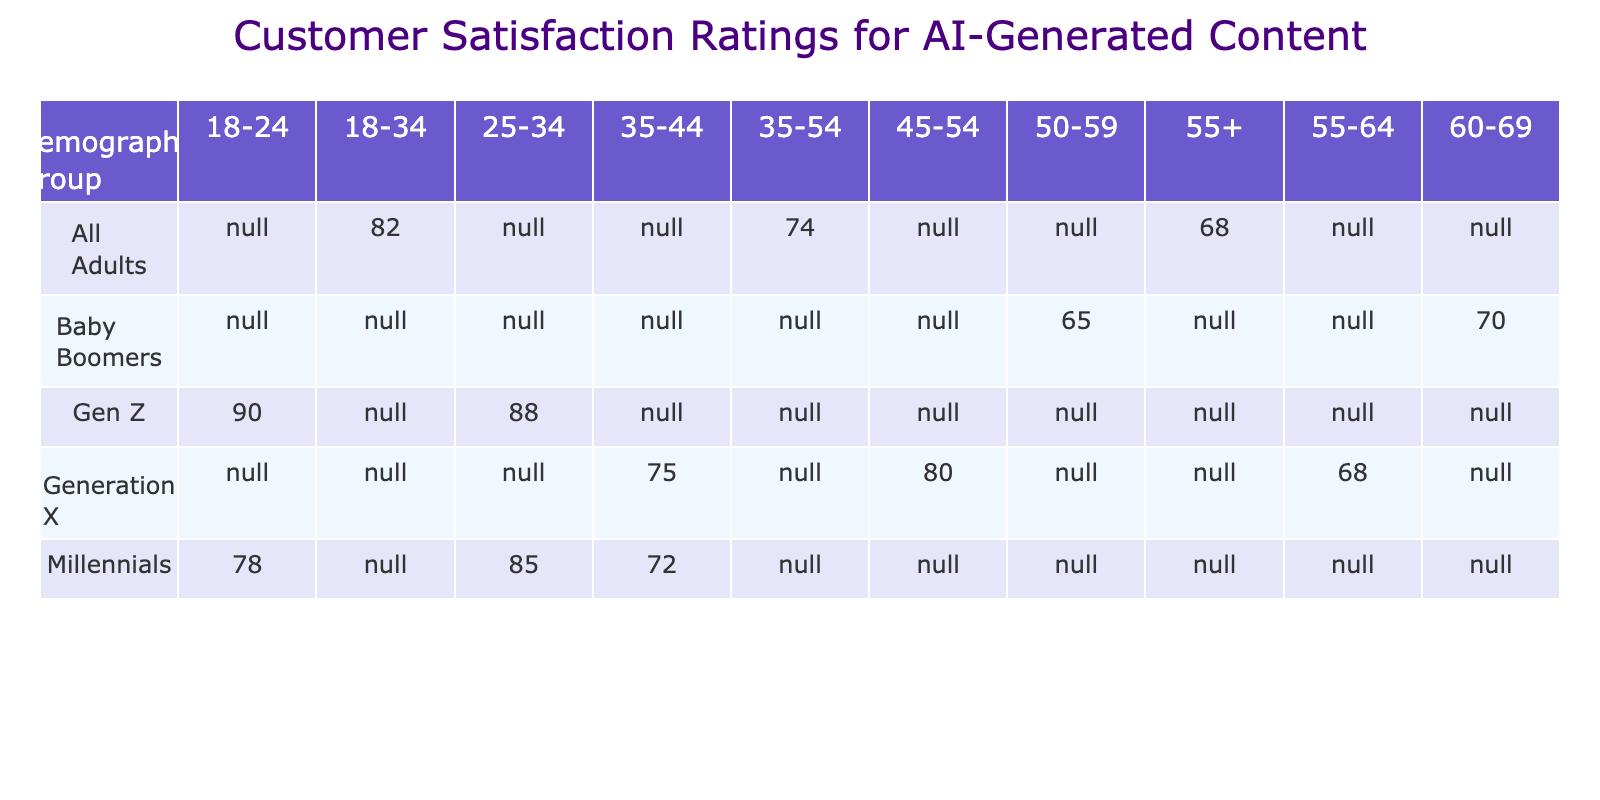What is the satisfaction rating for Gen Z in the 18-24 age group? The table shows the satisfaction rating for Gen Z in the 18-24 age group as 90.
Answer: 90 Which demographic group has the highest satisfaction rating in the age group 25-34? The table indicates that Millennials have the highest satisfaction rating in the 25-34 age group, with a rating of 85.
Answer: Millennials What is the average satisfaction rating for Baby Boomers across all their age groups listed? The ratings for Baby Boomers are 65 (50-59) and 70 (60-69). Adding these gives 135, and dividing by 2 results in an average of 67.5.
Answer: 67.5 Is the satisfaction rating for Generation X in the 55-64 age group higher than that for Baby Boomers in the 60-69 age group? The satisfaction rating for Generation X in the 55-64 age group is 68, while for Baby Boomers in the 60-69 age group it is 70. Therefore, it is false that Generation X has a higher rating.
Answer: No What is the difference between the highest and lowest satisfaction ratings for Millennials? The highest rating for Millennials is 85 (25-34 age group) and the lowest is 72 (35-44 age group). The difference is 85 - 72 = 13.
Answer: 13 What demographic group shows the lowest satisfaction rating among all age groups? The Baby Boomers in the 50-59 age group have the lowest rating, which is 65.
Answer: 65 Which age group has the highest overall satisfaction rating between all demographic groups? The table indicates that the 18-24 age group under Gen Z has the highest overall rating of 90 for that age group.
Answer: 90 Are satisfaction ratings for the age group 55+ higher than those for the age group 18-34? The satisfaction rating for the age group 55+ is 68, while for 18-34 (All Adults) it is 82. Therefore, it is false that ratings for 55+ are higher.
Answer: No 